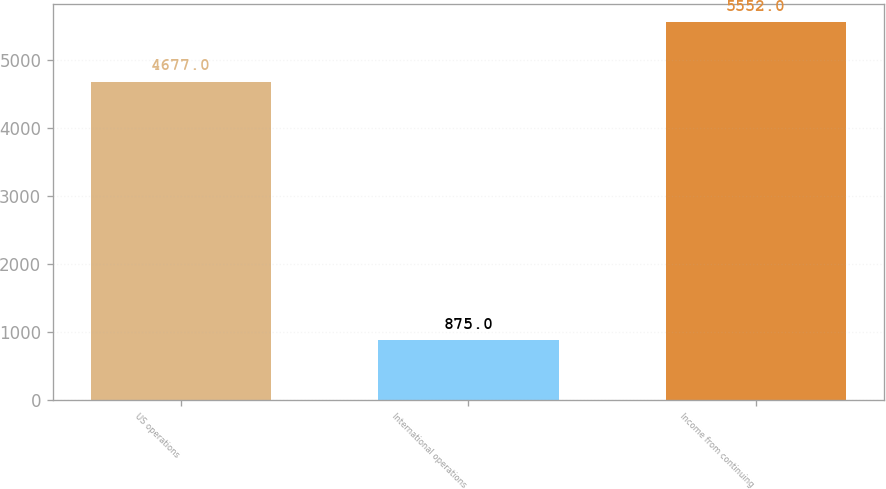<chart> <loc_0><loc_0><loc_500><loc_500><bar_chart><fcel>US operations<fcel>International operations<fcel>Income from continuing<nl><fcel>4677<fcel>875<fcel>5552<nl></chart> 